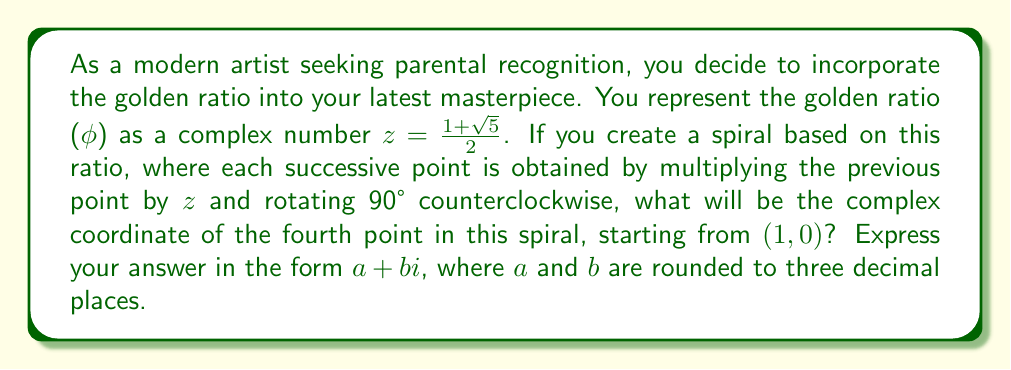Can you solve this math problem? Let's approach this step-by-step:

1) The golden ratio $\phi$ is represented as the complex number:

   $z = \frac{1 + \sqrt{5}}{2} \approx 1.618033988749895$

2) Starting from $(1,0)$, which in complex form is just $1$, we'll multiply by $z$ and rotate 90° counterclockwise three times.

3) Rotating 90° counterclockwise in the complex plane is equivalent to multiplying by $i$.

4) So, the sequence of points will be:
   
   - First point: $1$
   - Second point: $1 \cdot z \cdot i = (\frac{1 + \sqrt{5}}{2})i$
   - Third point: $(\frac{1 + \sqrt{5}}{2})i \cdot z \cdot i = -(\frac{1 + \sqrt{5}}{2})^2$
   - Fourth point: $-(\frac{1 + \sqrt{5}}{2})^2 \cdot z \cdot i = -(\frac{1 + \sqrt{5}}{2})^3 i$

5) Let's calculate $(\frac{1 + \sqrt{5}}{2})^3$:

   $$\begin{align}
   (\frac{1 + \sqrt{5}}{2})^3 &= (\frac{1 + \sqrt{5}}{2})^2 \cdot (\frac{1 + \sqrt{5}}{2}) \\
   &= (\frac{3 + \sqrt{5}}{2}) \cdot (\frac{1 + \sqrt{5}}{2}) \\
   &= \frac{3 + \sqrt{5} + 3\sqrt{5} + 5}{4} \\
   &= \frac{8 + 4\sqrt{5}}{4} \\
   &= 2 + \sqrt{5}
   \end{align}$$

6) Therefore, the fourth point is:

   $-(2 + \sqrt{5})i \approx -4.236067977499790i$

7) Rounding to three decimal places, we get $-4.236i$.
Answer: $0 - 4.236i$ 